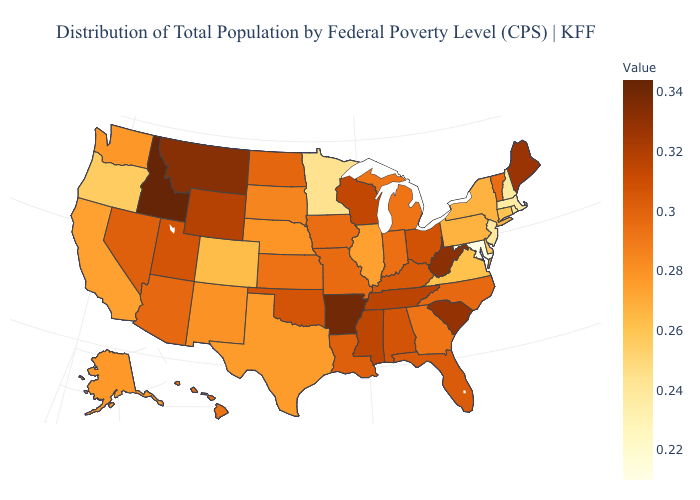Among the states that border Illinois , does Wisconsin have the highest value?
Quick response, please. Yes. Does Alaska have the highest value in the USA?
Keep it brief. No. Among the states that border Oklahoma , which have the lowest value?
Write a very short answer. Colorado. Among the states that border Idaho , does Washington have the highest value?
Concise answer only. No. Is the legend a continuous bar?
Be succinct. Yes. Which states have the highest value in the USA?
Concise answer only. Idaho. Does Maryland have the lowest value in the USA?
Short answer required. Yes. Which states hav the highest value in the South?
Be succinct. Arkansas. 